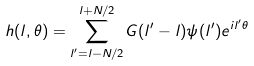Convert formula to latex. <formula><loc_0><loc_0><loc_500><loc_500>h ( l , \theta ) = \sum _ { l ^ { \prime } = l - N / 2 } ^ { l + N / 2 } G ( l ^ { \prime } - l ) \psi ( l ^ { \prime } ) e ^ { i l ^ { \prime } \theta }</formula> 